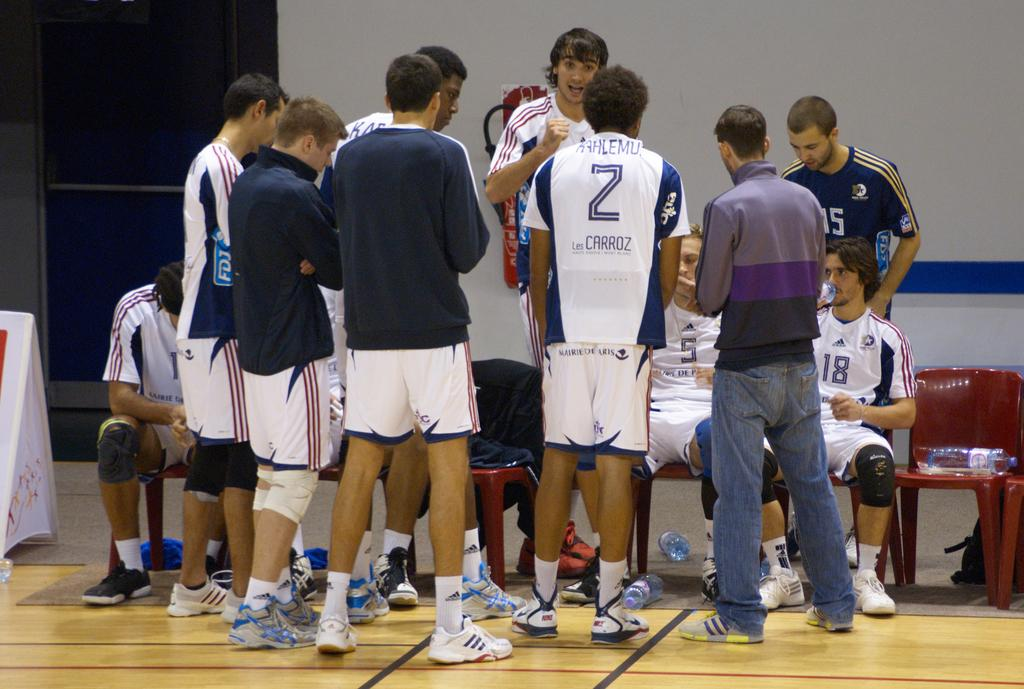<image>
Provide a brief description of the given image. A baseball team is having a team talk and most prominent wears a top with the number 2 on it and the words Les Carroz 